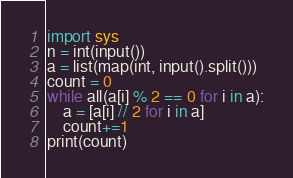Convert code to text. <code><loc_0><loc_0><loc_500><loc_500><_Python_>import sys
n = int(input())
a = list(map(int, input().split()))
count = 0
while all(a[i] % 2 == 0 for i in a):
    a = [a[i] // 2 for i in a]
    count+=1
print(count)</code> 